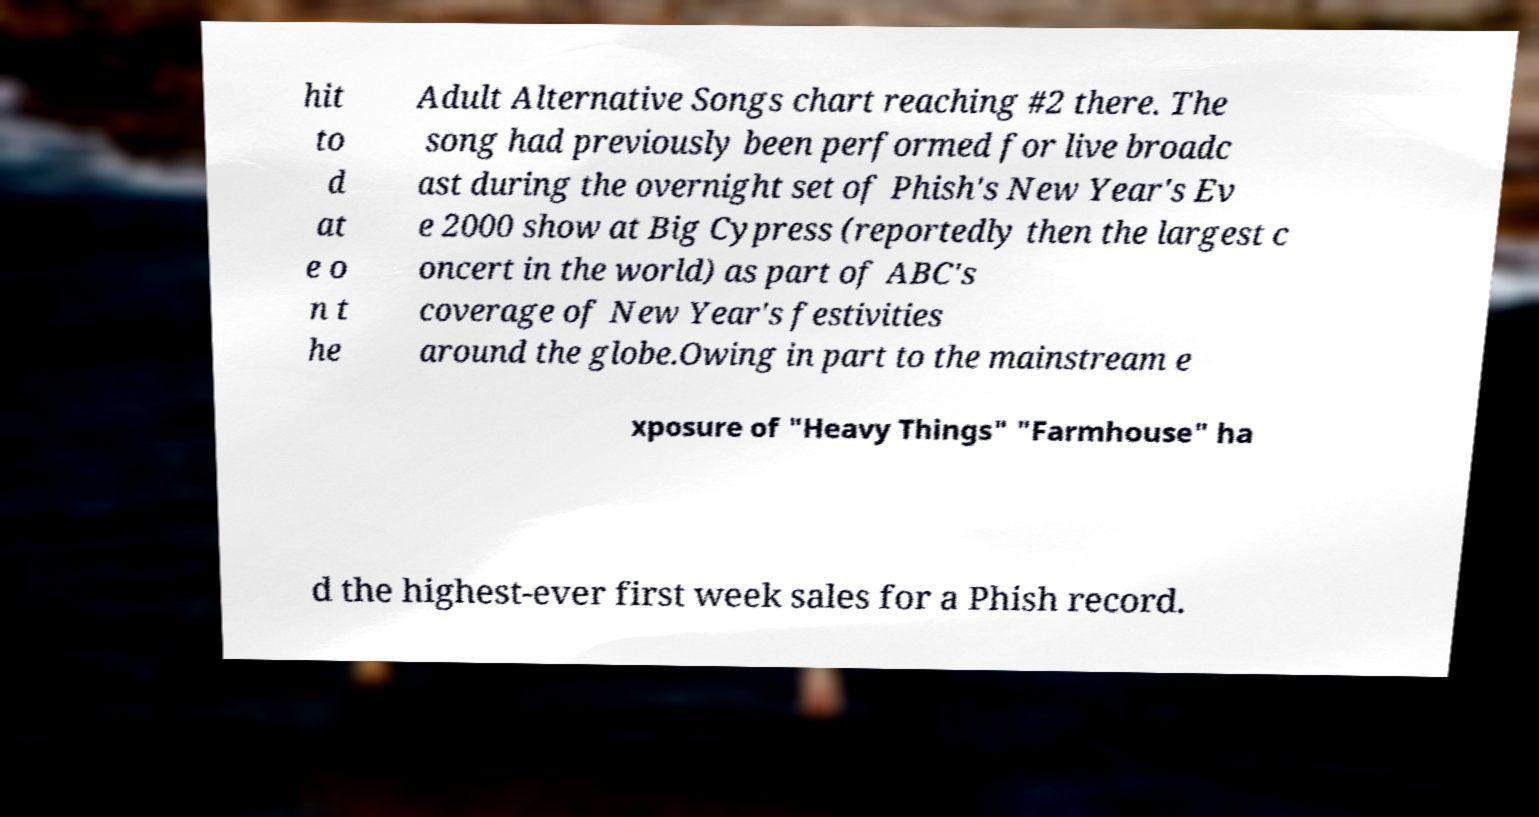Could you extract and type out the text from this image? hit to d at e o n t he Adult Alternative Songs chart reaching #2 there. The song had previously been performed for live broadc ast during the overnight set of Phish's New Year's Ev e 2000 show at Big Cypress (reportedly then the largest c oncert in the world) as part of ABC's coverage of New Year's festivities around the globe.Owing in part to the mainstream e xposure of "Heavy Things" "Farmhouse" ha d the highest-ever first week sales for a Phish record. 